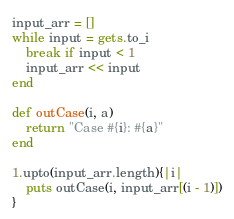<code> <loc_0><loc_0><loc_500><loc_500><_Ruby_>
input_arr = []
while input = gets.to_i
	break if input < 1
	input_arr << input
end

def outCase(i, a)
	return "Case #{i}: #{a}"
end

1.upto(input_arr.length){|i|
	puts outCase(i, input_arr[(i - 1)])
}</code> 